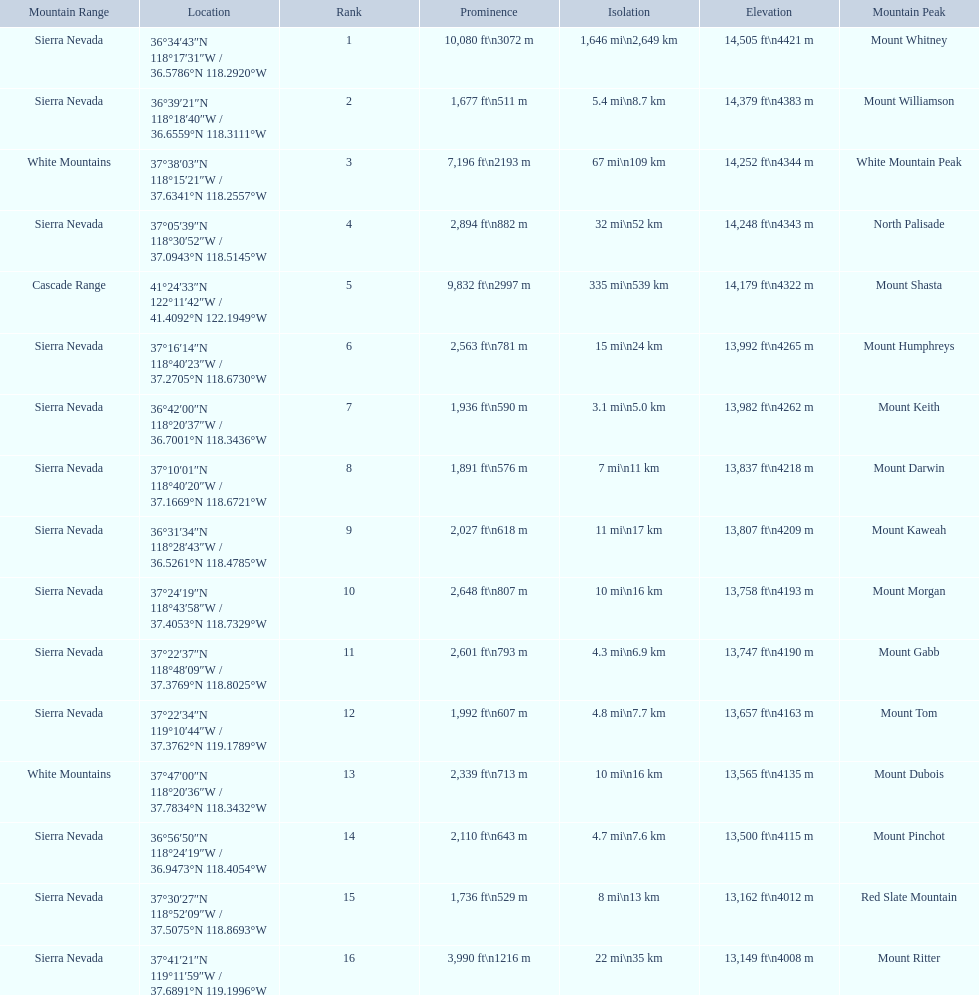Which are the highest mountain peaks in california? Mount Whitney, Mount Williamson, White Mountain Peak, North Palisade, Mount Shasta, Mount Humphreys, Mount Keith, Mount Darwin, Mount Kaweah, Mount Morgan, Mount Gabb, Mount Tom, Mount Dubois, Mount Pinchot, Red Slate Mountain, Mount Ritter. Of those, which are not in the sierra nevada range? White Mountain Peak, Mount Shasta, Mount Dubois. Could you parse the entire table as a dict? {'header': ['Mountain Range', 'Location', 'Rank', 'Prominence', 'Isolation', 'Elevation', 'Mountain Peak'], 'rows': [['Sierra Nevada', '36°34′43″N 118°17′31″W\ufeff / \ufeff36.5786°N 118.2920°W', '1', '10,080\xa0ft\\n3072\xa0m', '1,646\xa0mi\\n2,649\xa0km', '14,505\xa0ft\\n4421\xa0m', 'Mount Whitney'], ['Sierra Nevada', '36°39′21″N 118°18′40″W\ufeff / \ufeff36.6559°N 118.3111°W', '2', '1,677\xa0ft\\n511\xa0m', '5.4\xa0mi\\n8.7\xa0km', '14,379\xa0ft\\n4383\xa0m', 'Mount Williamson'], ['White Mountains', '37°38′03″N 118°15′21″W\ufeff / \ufeff37.6341°N 118.2557°W', '3', '7,196\xa0ft\\n2193\xa0m', '67\xa0mi\\n109\xa0km', '14,252\xa0ft\\n4344\xa0m', 'White Mountain Peak'], ['Sierra Nevada', '37°05′39″N 118°30′52″W\ufeff / \ufeff37.0943°N 118.5145°W', '4', '2,894\xa0ft\\n882\xa0m', '32\xa0mi\\n52\xa0km', '14,248\xa0ft\\n4343\xa0m', 'North Palisade'], ['Cascade Range', '41°24′33″N 122°11′42″W\ufeff / \ufeff41.4092°N 122.1949°W', '5', '9,832\xa0ft\\n2997\xa0m', '335\xa0mi\\n539\xa0km', '14,179\xa0ft\\n4322\xa0m', 'Mount Shasta'], ['Sierra Nevada', '37°16′14″N 118°40′23″W\ufeff / \ufeff37.2705°N 118.6730°W', '6', '2,563\xa0ft\\n781\xa0m', '15\xa0mi\\n24\xa0km', '13,992\xa0ft\\n4265\xa0m', 'Mount Humphreys'], ['Sierra Nevada', '36°42′00″N 118°20′37″W\ufeff / \ufeff36.7001°N 118.3436°W', '7', '1,936\xa0ft\\n590\xa0m', '3.1\xa0mi\\n5.0\xa0km', '13,982\xa0ft\\n4262\xa0m', 'Mount Keith'], ['Sierra Nevada', '37°10′01″N 118°40′20″W\ufeff / \ufeff37.1669°N 118.6721°W', '8', '1,891\xa0ft\\n576\xa0m', '7\xa0mi\\n11\xa0km', '13,837\xa0ft\\n4218\xa0m', 'Mount Darwin'], ['Sierra Nevada', '36°31′34″N 118°28′43″W\ufeff / \ufeff36.5261°N 118.4785°W', '9', '2,027\xa0ft\\n618\xa0m', '11\xa0mi\\n17\xa0km', '13,807\xa0ft\\n4209\xa0m', 'Mount Kaweah'], ['Sierra Nevada', '37°24′19″N 118°43′58″W\ufeff / \ufeff37.4053°N 118.7329°W', '10', '2,648\xa0ft\\n807\xa0m', '10\xa0mi\\n16\xa0km', '13,758\xa0ft\\n4193\xa0m', 'Mount Morgan'], ['Sierra Nevada', '37°22′37″N 118°48′09″W\ufeff / \ufeff37.3769°N 118.8025°W', '11', '2,601\xa0ft\\n793\xa0m', '4.3\xa0mi\\n6.9\xa0km', '13,747\xa0ft\\n4190\xa0m', 'Mount Gabb'], ['Sierra Nevada', '37°22′34″N 119°10′44″W\ufeff / \ufeff37.3762°N 119.1789°W', '12', '1,992\xa0ft\\n607\xa0m', '4.8\xa0mi\\n7.7\xa0km', '13,657\xa0ft\\n4163\xa0m', 'Mount Tom'], ['White Mountains', '37°47′00″N 118°20′36″W\ufeff / \ufeff37.7834°N 118.3432°W', '13', '2,339\xa0ft\\n713\xa0m', '10\xa0mi\\n16\xa0km', '13,565\xa0ft\\n4135\xa0m', 'Mount Dubois'], ['Sierra Nevada', '36°56′50″N 118°24′19″W\ufeff / \ufeff36.9473°N 118.4054°W', '14', '2,110\xa0ft\\n643\xa0m', '4.7\xa0mi\\n7.6\xa0km', '13,500\xa0ft\\n4115\xa0m', 'Mount Pinchot'], ['Sierra Nevada', '37°30′27″N 118°52′09″W\ufeff / \ufeff37.5075°N 118.8693°W', '15', '1,736\xa0ft\\n529\xa0m', '8\xa0mi\\n13\xa0km', '13,162\xa0ft\\n4012\xa0m', 'Red Slate Mountain'], ['Sierra Nevada', '37°41′21″N 119°11′59″W\ufeff / \ufeff37.6891°N 119.1996°W', '16', '3,990\xa0ft\\n1216\xa0m', '22\xa0mi\\n35\xa0km', '13,149\xa0ft\\n4008\xa0m', 'Mount Ritter']]} Of the mountains not in the sierra nevada range, which is the only mountain in the cascades? Mount Shasta. 